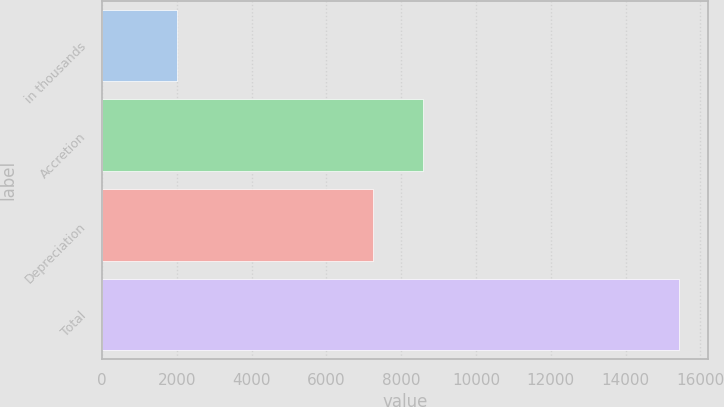<chart> <loc_0><loc_0><loc_500><loc_500><bar_chart><fcel>in thousands<fcel>Accretion<fcel>Depreciation<fcel>Total<nl><fcel>2011<fcel>8584.6<fcel>7242<fcel>15437<nl></chart> 